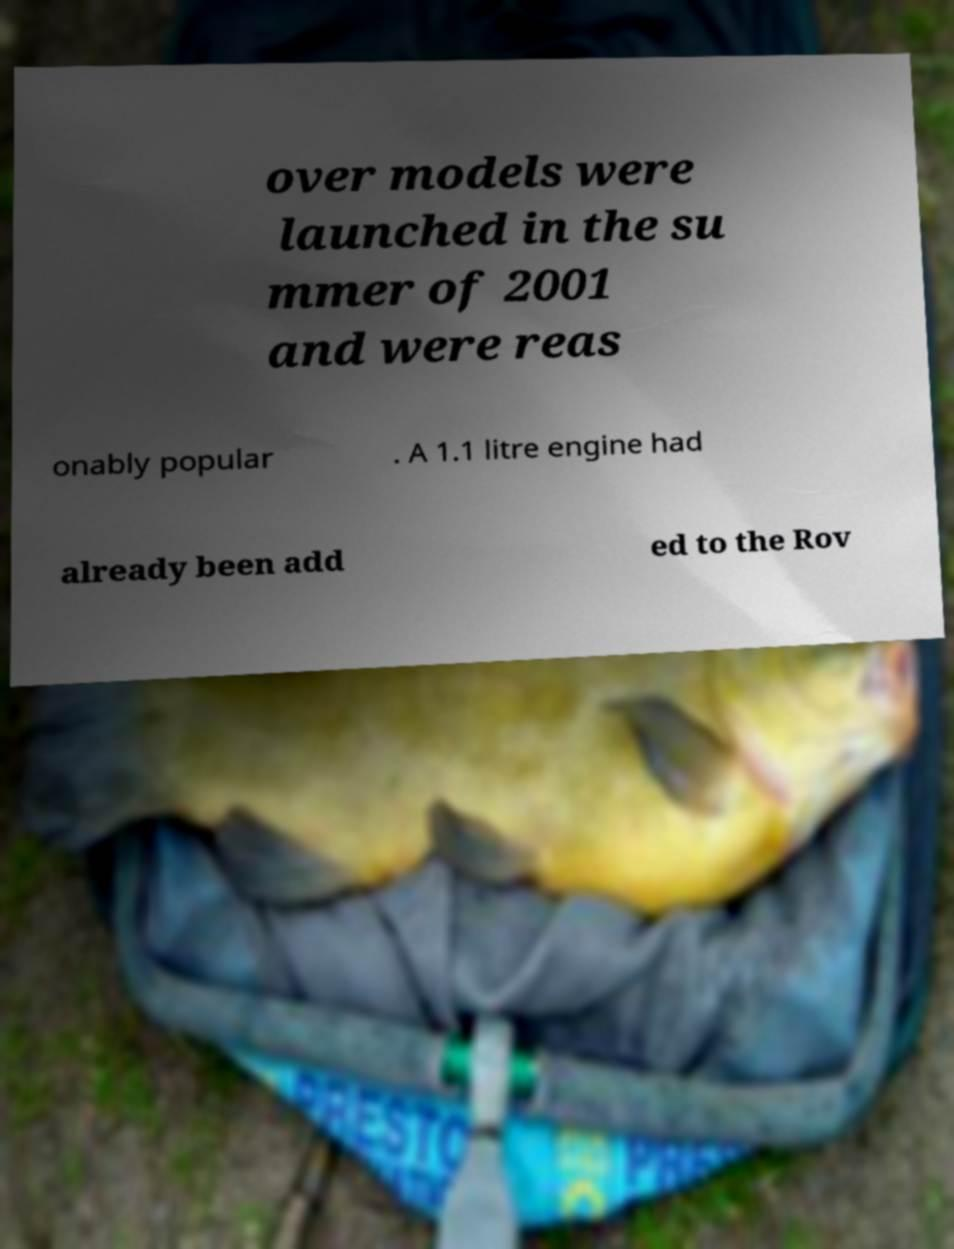Could you assist in decoding the text presented in this image and type it out clearly? over models were launched in the su mmer of 2001 and were reas onably popular . A 1.1 litre engine had already been add ed to the Rov 